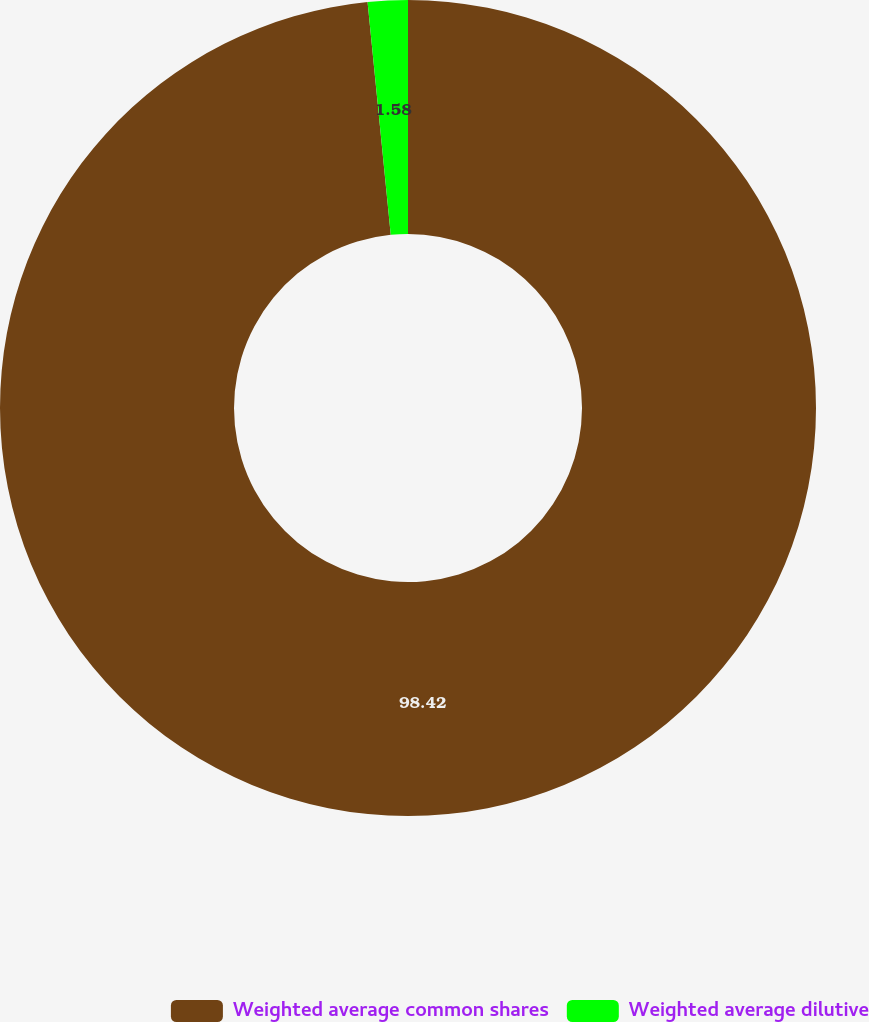Convert chart. <chart><loc_0><loc_0><loc_500><loc_500><pie_chart><fcel>Weighted average common shares<fcel>Weighted average dilutive<nl><fcel>98.42%<fcel>1.58%<nl></chart> 